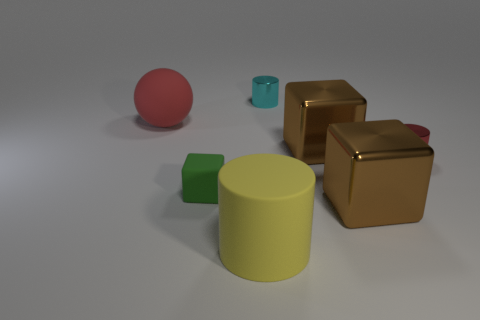Is there a cylinder of the same color as the matte sphere?
Ensure brevity in your answer.  Yes. What number of things are either big green shiny cubes or red matte things left of the big cylinder?
Your answer should be compact. 1. What is the color of the large cylinder that is made of the same material as the red ball?
Your answer should be compact. Yellow. What number of cylinders are made of the same material as the yellow object?
Offer a terse response. 0. What number of big brown metallic blocks are there?
Make the answer very short. 2. Does the tiny metal thing in front of the matte ball have the same color as the sphere behind the red metallic object?
Keep it short and to the point. Yes. How many brown things are in front of the matte block?
Offer a terse response. 1. Is there a yellow rubber object of the same shape as the small green object?
Offer a terse response. No. Is the tiny object on the left side of the large yellow rubber cylinder made of the same material as the big brown block behind the green rubber object?
Provide a short and direct response. No. What is the size of the sphere in front of the small cylinder that is left of the red thing that is right of the yellow rubber thing?
Ensure brevity in your answer.  Large. 